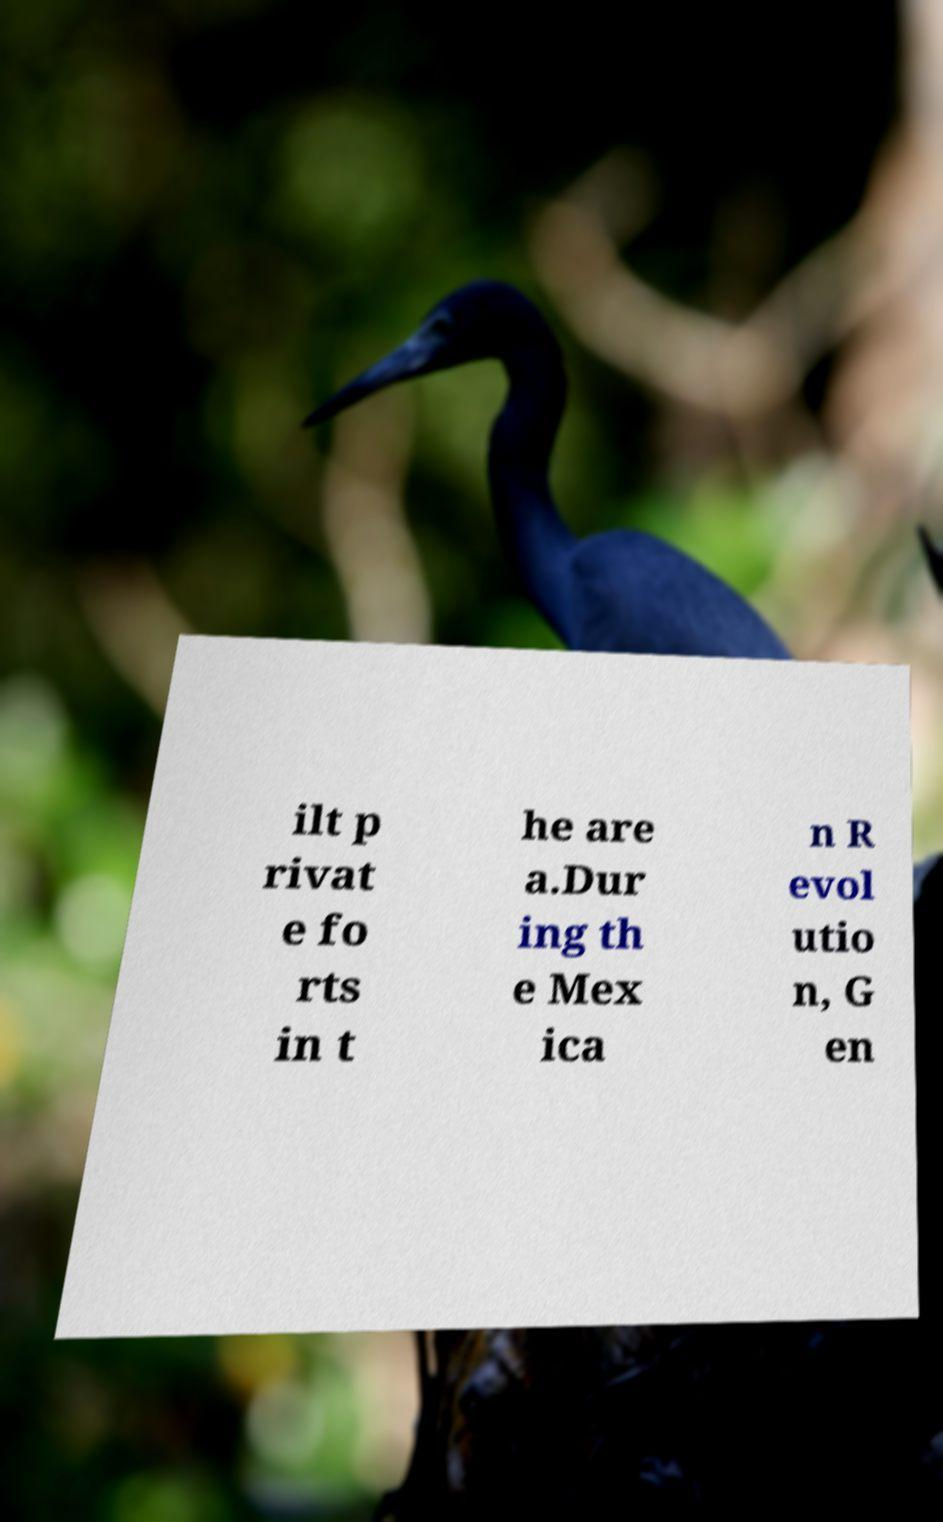Can you read and provide the text displayed in the image?This photo seems to have some interesting text. Can you extract and type it out for me? ilt p rivat e fo rts in t he are a.Dur ing th e Mex ica n R evol utio n, G en 